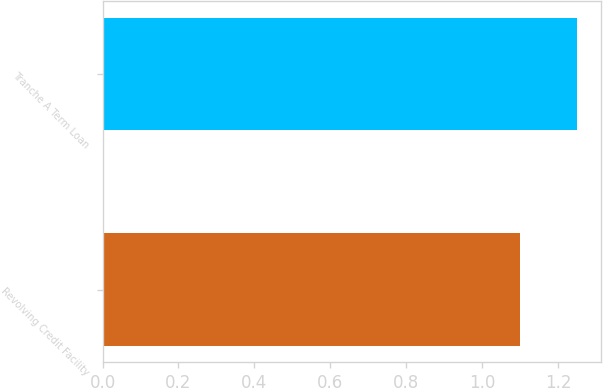Convert chart to OTSL. <chart><loc_0><loc_0><loc_500><loc_500><bar_chart><fcel>Revolving Credit Facility<fcel>Tranche A Term Loan<nl><fcel>1.1<fcel>1.25<nl></chart> 